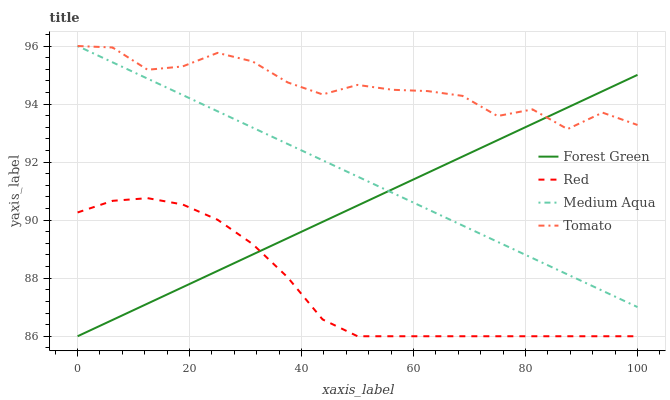Does Red have the minimum area under the curve?
Answer yes or no. Yes. Does Tomato have the maximum area under the curve?
Answer yes or no. Yes. Does Forest Green have the minimum area under the curve?
Answer yes or no. No. Does Forest Green have the maximum area under the curve?
Answer yes or no. No. Is Forest Green the smoothest?
Answer yes or no. Yes. Is Tomato the roughest?
Answer yes or no. Yes. Is Medium Aqua the smoothest?
Answer yes or no. No. Is Medium Aqua the roughest?
Answer yes or no. No. Does Forest Green have the lowest value?
Answer yes or no. Yes. Does Medium Aqua have the lowest value?
Answer yes or no. No. Does Medium Aqua have the highest value?
Answer yes or no. Yes. Does Forest Green have the highest value?
Answer yes or no. No. Is Red less than Medium Aqua?
Answer yes or no. Yes. Is Tomato greater than Red?
Answer yes or no. Yes. Does Forest Green intersect Medium Aqua?
Answer yes or no. Yes. Is Forest Green less than Medium Aqua?
Answer yes or no. No. Is Forest Green greater than Medium Aqua?
Answer yes or no. No. Does Red intersect Medium Aqua?
Answer yes or no. No. 